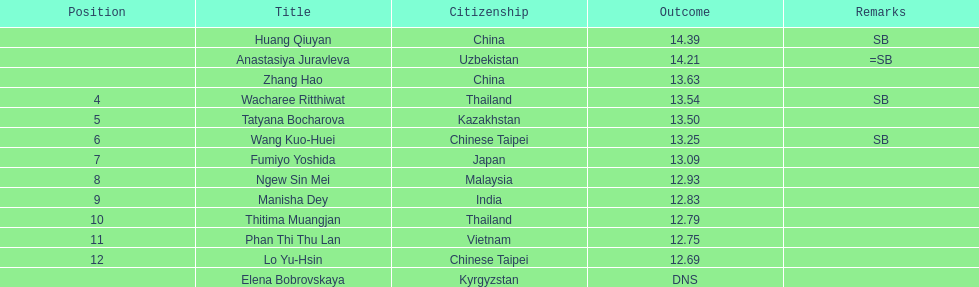How many points apart were the 1st place competitor and the 12th place competitor? 1.7. 